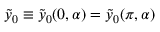<formula> <loc_0><loc_0><loc_500><loc_500>\tilde { y } _ { 0 } \equiv \tilde { y } _ { 0 } ( 0 , \alpha ) = \tilde { y } _ { 0 } ( \pi , \alpha )</formula> 